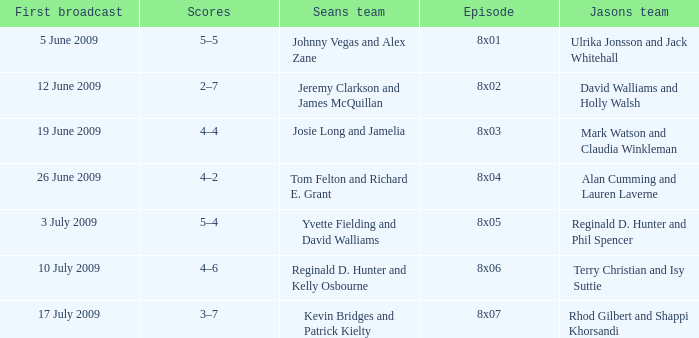Who was on Jason's team for the 12 June 2009 episode? David Walliams and Holly Walsh. 